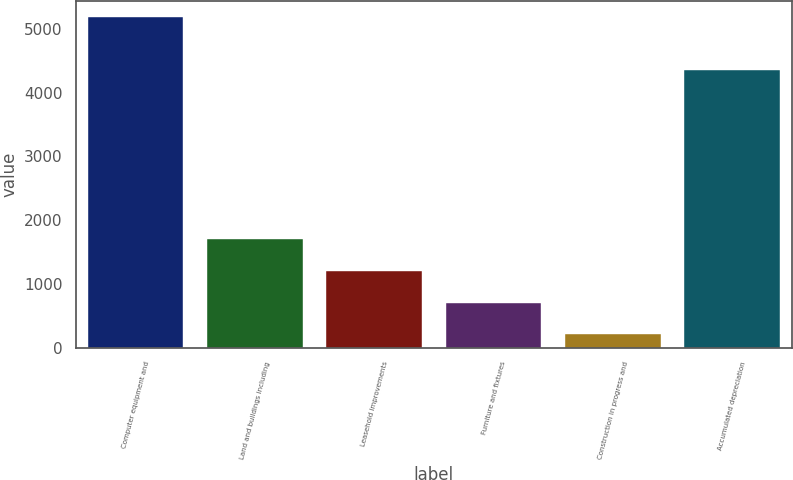Convert chart to OTSL. <chart><loc_0><loc_0><loc_500><loc_500><bar_chart><fcel>Computer equipment and<fcel>Land and buildings including<fcel>Leasehold improvements<fcel>Furniture and fixtures<fcel>Construction in progress and<fcel>Accumulated depreciation<nl><fcel>5179<fcel>1699.3<fcel>1202.2<fcel>705.1<fcel>208<fcel>4360<nl></chart> 